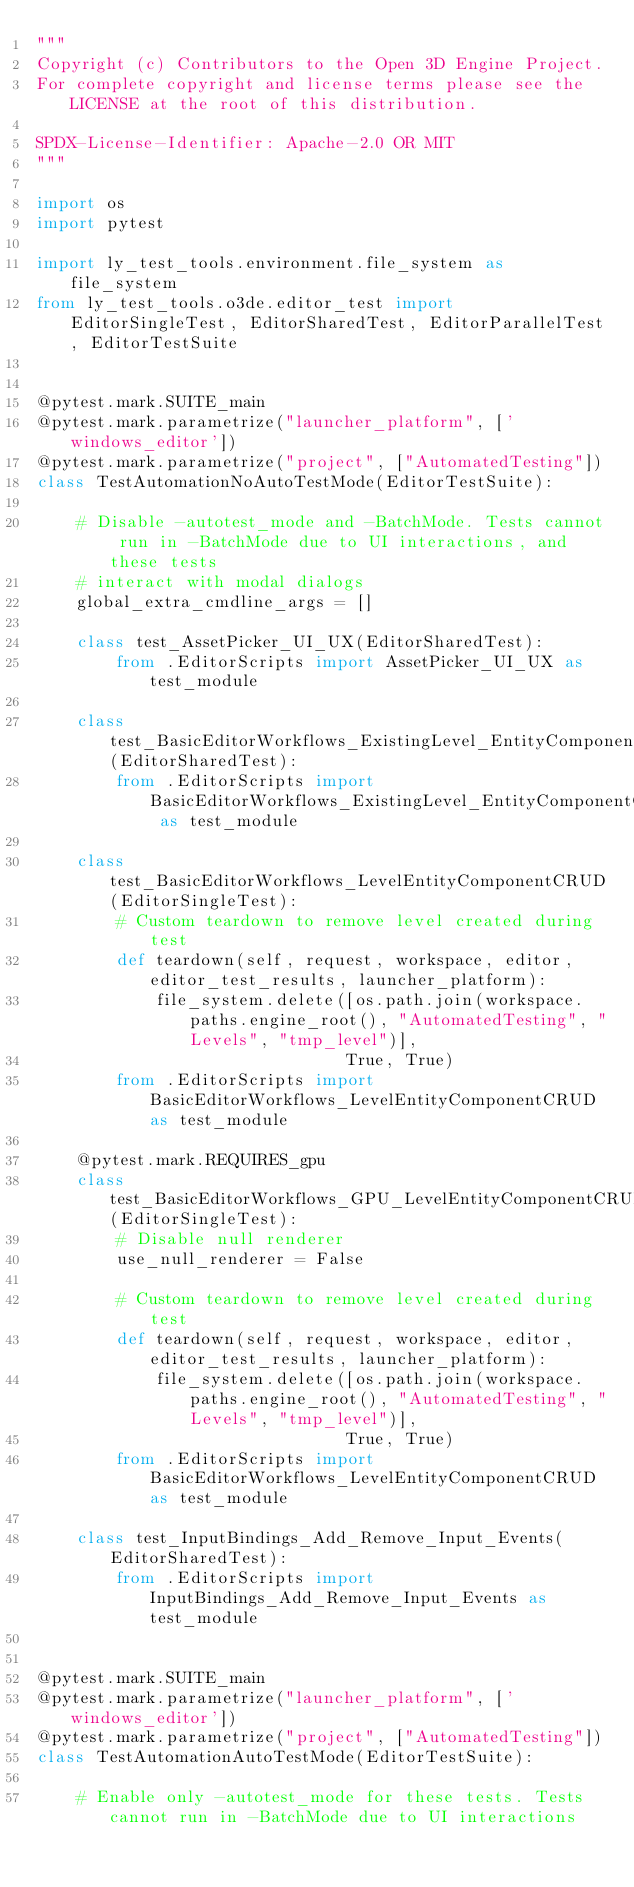<code> <loc_0><loc_0><loc_500><loc_500><_Python_>"""
Copyright (c) Contributors to the Open 3D Engine Project.
For complete copyright and license terms please see the LICENSE at the root of this distribution.

SPDX-License-Identifier: Apache-2.0 OR MIT
"""

import os
import pytest

import ly_test_tools.environment.file_system as file_system
from ly_test_tools.o3de.editor_test import EditorSingleTest, EditorSharedTest, EditorParallelTest, EditorTestSuite


@pytest.mark.SUITE_main
@pytest.mark.parametrize("launcher_platform", ['windows_editor'])
@pytest.mark.parametrize("project", ["AutomatedTesting"])
class TestAutomationNoAutoTestMode(EditorTestSuite):

    # Disable -autotest_mode and -BatchMode. Tests cannot run in -BatchMode due to UI interactions, and these tests
    # interact with modal dialogs
    global_extra_cmdline_args = []

    class test_AssetPicker_UI_UX(EditorSharedTest):
        from .EditorScripts import AssetPicker_UI_UX as test_module

    class test_BasicEditorWorkflows_ExistingLevel_EntityComponentCRUD(EditorSharedTest):
        from .EditorScripts import BasicEditorWorkflows_ExistingLevel_EntityComponentCRUD as test_module

    class test_BasicEditorWorkflows_LevelEntityComponentCRUD(EditorSingleTest):
        # Custom teardown to remove level created during test
        def teardown(self, request, workspace, editor, editor_test_results, launcher_platform):
            file_system.delete([os.path.join(workspace.paths.engine_root(), "AutomatedTesting", "Levels", "tmp_level")],
                               True, True)
        from .EditorScripts import BasicEditorWorkflows_LevelEntityComponentCRUD as test_module

    @pytest.mark.REQUIRES_gpu
    class test_BasicEditorWorkflows_GPU_LevelEntityComponentCRUD(EditorSingleTest):
        # Disable null renderer
        use_null_renderer = False

        # Custom teardown to remove level created during test
        def teardown(self, request, workspace, editor, editor_test_results, launcher_platform):
            file_system.delete([os.path.join(workspace.paths.engine_root(), "AutomatedTesting", "Levels", "tmp_level")],
                               True, True)
        from .EditorScripts import BasicEditorWorkflows_LevelEntityComponentCRUD as test_module

    class test_InputBindings_Add_Remove_Input_Events(EditorSharedTest):
        from .EditorScripts import InputBindings_Add_Remove_Input_Events as test_module


@pytest.mark.SUITE_main
@pytest.mark.parametrize("launcher_platform", ['windows_editor'])
@pytest.mark.parametrize("project", ["AutomatedTesting"])
class TestAutomationAutoTestMode(EditorTestSuite):

    # Enable only -autotest_mode for these tests. Tests cannot run in -BatchMode due to UI interactions</code> 